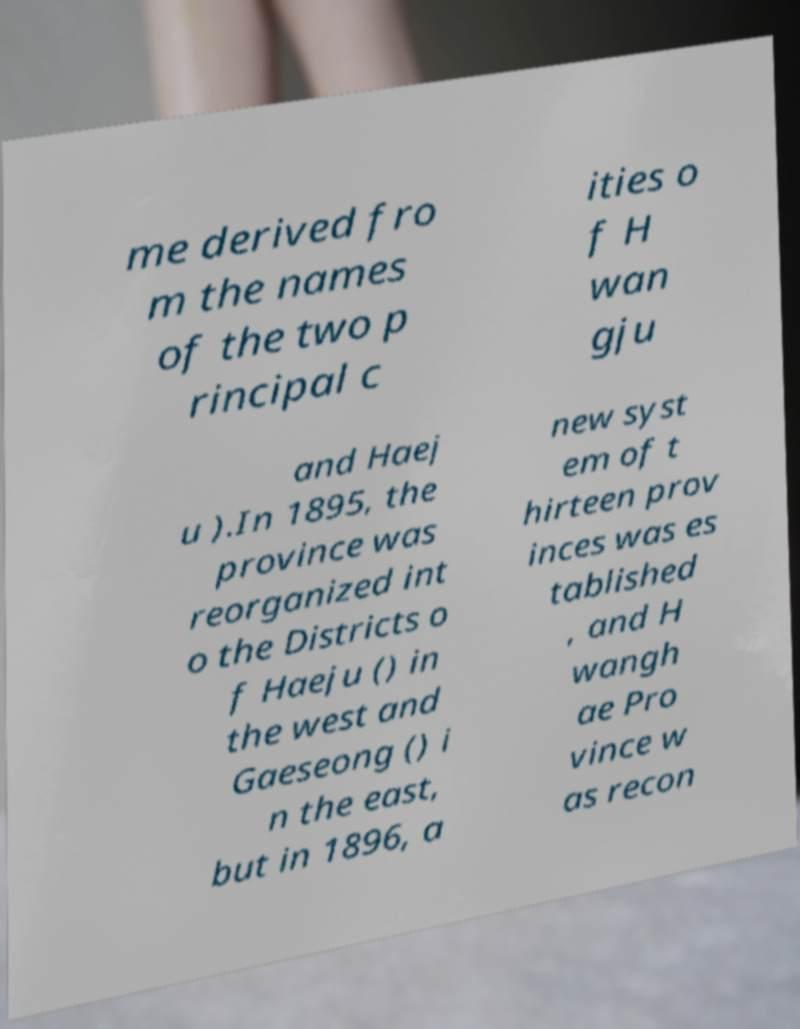What messages or text are displayed in this image? I need them in a readable, typed format. me derived fro m the names of the two p rincipal c ities o f H wan gju and Haej u ).In 1895, the province was reorganized int o the Districts o f Haeju () in the west and Gaeseong () i n the east, but in 1896, a new syst em of t hirteen prov inces was es tablished , and H wangh ae Pro vince w as recon 